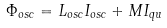Convert formula to latex. <formula><loc_0><loc_0><loc_500><loc_500>\Phi _ { o s c } = L _ { o s c } I _ { o s c } + M I _ { q u }</formula> 